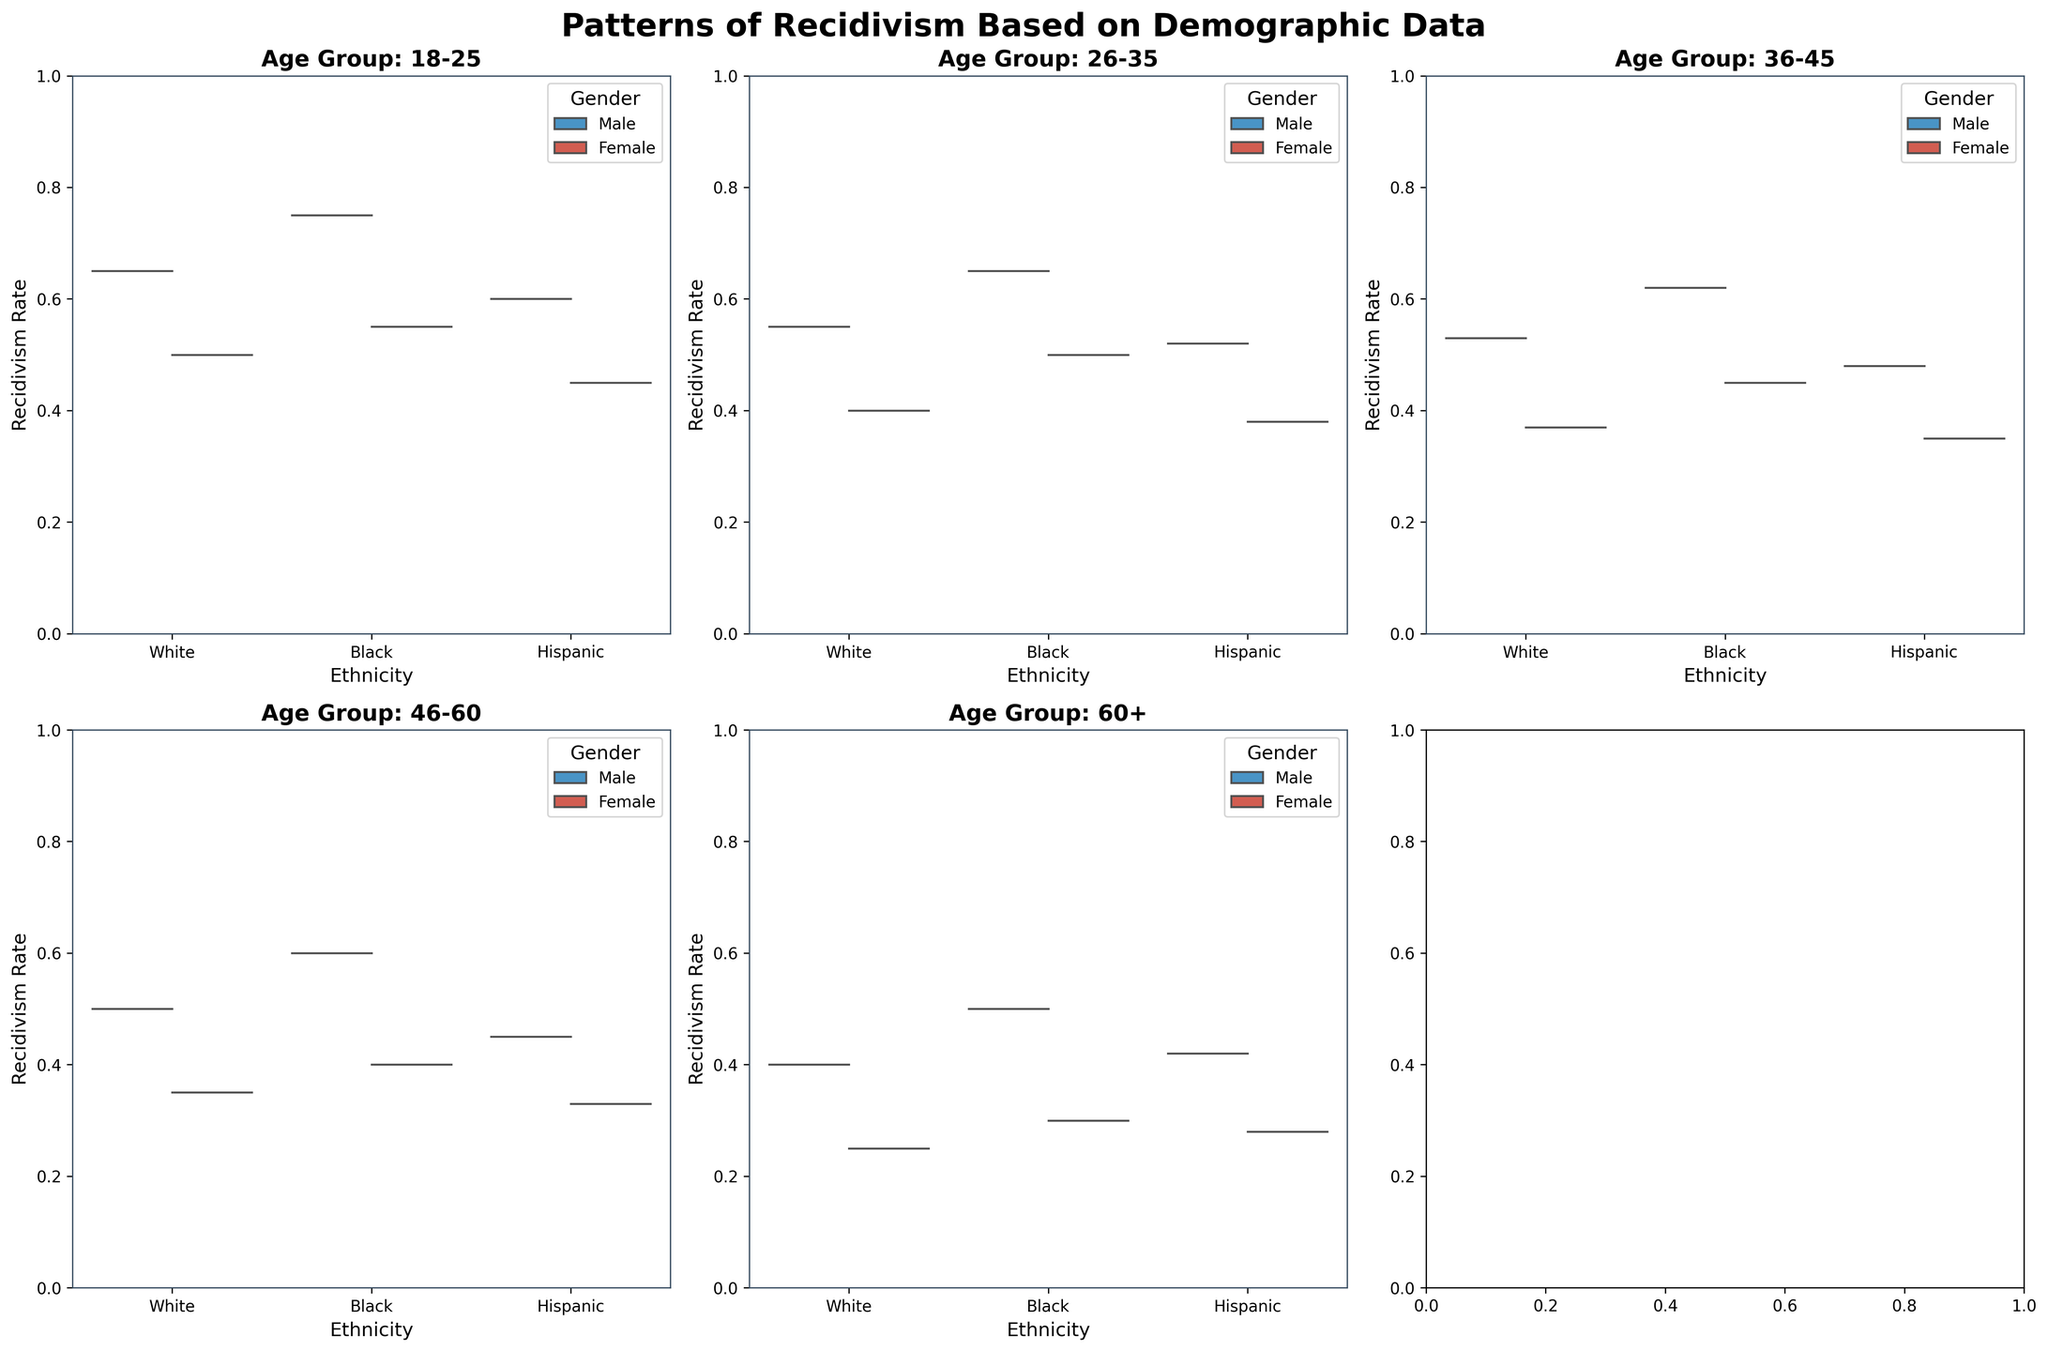What is the title of the figure? The title can be found at the top of the figure, where it is prominently displayed. The title provides a summary of the visual information presented in the figure.
Answer: Patterns of Recidivism Based on Demographic Data How many subplots are there in the figure? The figure is arranged in a grid format with titles for each subplot. You can count the individual plots to find the total number of subplots.
Answer: 6 What age group has the highest recidivism rate for Black males? Look for the subplot titled with the relevant age group. Identify the distribution shapes for Black males and compare their positions on the y-axis across the subplots. The topmost point represents the highest rate.
Answer: 18-25 What is the median recidivism rate for Hispanic females in the 36-45 age group? Locate the subplot for the 36-45 age group. Identify the shape of the violin plot for Hispanic females and find the median line (typically represented by a thicker line within the shape).
Answer: 0.35 Which gender generally has a lower recidivism rate according to the plots? Observe the split violins in each subplot. One half of the violin is for males and the other for females. Determine which side has lower positions on the y-axis across multiple subplots.
Answer: Female In the 46-60 age group, how does the recidivism rate trend for Hispanic males compare to Hispanic females? Locate the subplot for the 46-60 age group. Compare the shapes of the violins for Hispanic males and females, observing the overall trend and quartiles.
Answer: Higher for males What ethnicity in the 60+ age group has the highest male recidivism rate? Identify the subplot for the 60+ age group. Compare the topmost points of the violin shapes for each ethnicity for males. The highest point indicates the highest rate.
Answer: Black In the 26-35 age group, what is the difference in recidivism rate between Black males and females? Find the subplot for the 26-35 age group. Observe the median lines within the violins for Black males and females, then compute the difference in their y-axis positions.
Answer: 0.15 Which ethnicity has the broadest distribution of recidivism rates among White males in the 26-35 age group? Look at the subplot for the 26-35 age group. Observe the width and spread of the violin shapes for White males across different ethnicities. The broadest shape indicates the broadest distribution.
Answer: White What trend do you see in the recidivism rate for Black females across different age groups? Examine the recidivism rates of Black females across all subplots, noting the position and shape of the violins along the y-axis for each age group. Identify if there is an increasing or decreasing trend.
Answer: Decreasing trend 